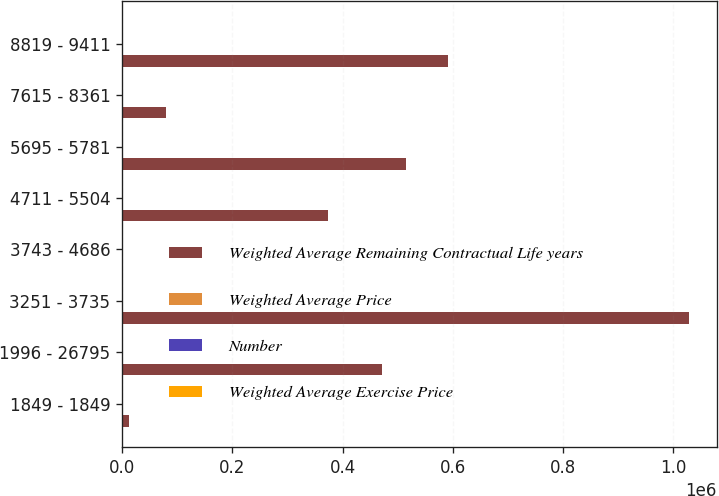Convert chart to OTSL. <chart><loc_0><loc_0><loc_500><loc_500><stacked_bar_chart><ecel><fcel>1849 - 1849<fcel>1996 - 26795<fcel>3251 - 3735<fcel>3743 - 4686<fcel>4711 - 5504<fcel>5695 - 5781<fcel>7615 - 8361<fcel>8819 - 9411<nl><fcel>Weighted Average Remaining Contractual Life years<fcel>12000<fcel>472085<fcel>1.02755e+06<fcel>42.84<fcel>373550<fcel>515375<fcel>79375<fcel>590624<nl><fcel>Weighted Average Price<fcel>0.42<fcel>0.94<fcel>5.83<fcel>4.94<fcel>7.8<fcel>1.73<fcel>3.24<fcel>2.58<nl><fcel>Number<fcel>18.49<fcel>20.96<fcel>37.15<fcel>42.81<fcel>48.39<fcel>56.97<fcel>81.34<fcel>92.57<nl><fcel>Weighted Average Exercise Price<fcel>18.49<fcel>20.96<fcel>37.33<fcel>42.84<fcel>48.28<fcel>56.97<fcel>81.34<fcel>92.57<nl></chart> 